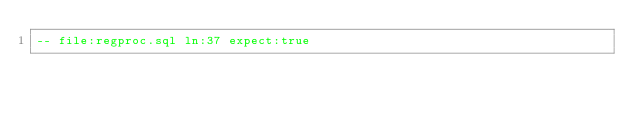Convert code to text. <code><loc_0><loc_0><loc_500><loc_500><_SQL_>-- file:regproc.sql ln:37 expect:true</code> 